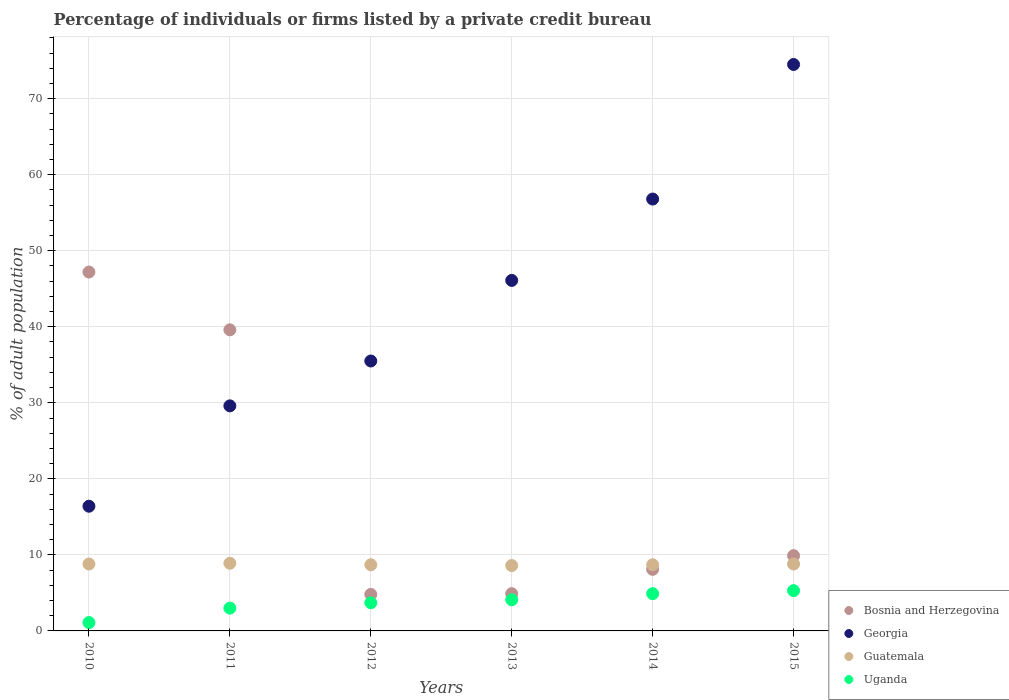Across all years, what is the maximum percentage of population listed by a private credit bureau in Uganda?
Offer a very short reply. 5.3. In which year was the percentage of population listed by a private credit bureau in Uganda maximum?
Ensure brevity in your answer.  2015. In which year was the percentage of population listed by a private credit bureau in Bosnia and Herzegovina minimum?
Offer a terse response. 2012. What is the total percentage of population listed by a private credit bureau in Georgia in the graph?
Give a very brief answer. 258.9. What is the difference between the percentage of population listed by a private credit bureau in Uganda in 2011 and that in 2015?
Give a very brief answer. -2.3. What is the difference between the percentage of population listed by a private credit bureau in Georgia in 2015 and the percentage of population listed by a private credit bureau in Uganda in 2013?
Offer a very short reply. 70.4. What is the average percentage of population listed by a private credit bureau in Uganda per year?
Your answer should be compact. 3.68. What is the difference between the highest and the second highest percentage of population listed by a private credit bureau in Georgia?
Make the answer very short. 17.7. What is the difference between the highest and the lowest percentage of population listed by a private credit bureau in Uganda?
Provide a succinct answer. 4.2. Does the percentage of population listed by a private credit bureau in Bosnia and Herzegovina monotonically increase over the years?
Make the answer very short. No. Is the percentage of population listed by a private credit bureau in Uganda strictly less than the percentage of population listed by a private credit bureau in Georgia over the years?
Your answer should be very brief. Yes. How many years are there in the graph?
Offer a very short reply. 6. What is the difference between two consecutive major ticks on the Y-axis?
Ensure brevity in your answer.  10. Does the graph contain any zero values?
Your answer should be very brief. No. How are the legend labels stacked?
Ensure brevity in your answer.  Vertical. What is the title of the graph?
Make the answer very short. Percentage of individuals or firms listed by a private credit bureau. What is the label or title of the X-axis?
Offer a very short reply. Years. What is the label or title of the Y-axis?
Offer a terse response. % of adult population. What is the % of adult population in Bosnia and Herzegovina in 2010?
Make the answer very short. 47.2. What is the % of adult population in Georgia in 2010?
Your response must be concise. 16.4. What is the % of adult population of Guatemala in 2010?
Ensure brevity in your answer.  8.8. What is the % of adult population of Bosnia and Herzegovina in 2011?
Provide a succinct answer. 39.6. What is the % of adult population in Georgia in 2011?
Ensure brevity in your answer.  29.6. What is the % of adult population of Georgia in 2012?
Provide a short and direct response. 35.5. What is the % of adult population in Uganda in 2012?
Offer a very short reply. 3.7. What is the % of adult population of Bosnia and Herzegovina in 2013?
Provide a short and direct response. 4.9. What is the % of adult population of Georgia in 2013?
Your answer should be very brief. 46.1. What is the % of adult population of Guatemala in 2013?
Your response must be concise. 8.6. What is the % of adult population of Bosnia and Herzegovina in 2014?
Make the answer very short. 8.1. What is the % of adult population in Georgia in 2014?
Your response must be concise. 56.8. What is the % of adult population of Guatemala in 2014?
Provide a succinct answer. 8.7. What is the % of adult population in Bosnia and Herzegovina in 2015?
Keep it short and to the point. 9.9. What is the % of adult population in Georgia in 2015?
Make the answer very short. 74.5. What is the % of adult population of Guatemala in 2015?
Your answer should be compact. 8.8. Across all years, what is the maximum % of adult population of Bosnia and Herzegovina?
Give a very brief answer. 47.2. Across all years, what is the maximum % of adult population of Georgia?
Offer a very short reply. 74.5. Across all years, what is the maximum % of adult population of Uganda?
Keep it short and to the point. 5.3. Across all years, what is the minimum % of adult population of Georgia?
Your response must be concise. 16.4. Across all years, what is the minimum % of adult population of Uganda?
Give a very brief answer. 1.1. What is the total % of adult population in Bosnia and Herzegovina in the graph?
Provide a short and direct response. 114.5. What is the total % of adult population of Georgia in the graph?
Make the answer very short. 258.9. What is the total % of adult population in Guatemala in the graph?
Your answer should be compact. 52.5. What is the total % of adult population of Uganda in the graph?
Ensure brevity in your answer.  22.1. What is the difference between the % of adult population of Bosnia and Herzegovina in 2010 and that in 2011?
Provide a succinct answer. 7.6. What is the difference between the % of adult population in Bosnia and Herzegovina in 2010 and that in 2012?
Your answer should be compact. 42.4. What is the difference between the % of adult population of Georgia in 2010 and that in 2012?
Provide a short and direct response. -19.1. What is the difference between the % of adult population of Guatemala in 2010 and that in 2012?
Offer a very short reply. 0.1. What is the difference between the % of adult population in Uganda in 2010 and that in 2012?
Keep it short and to the point. -2.6. What is the difference between the % of adult population in Bosnia and Herzegovina in 2010 and that in 2013?
Your answer should be compact. 42.3. What is the difference between the % of adult population of Georgia in 2010 and that in 2013?
Offer a terse response. -29.7. What is the difference between the % of adult population of Uganda in 2010 and that in 2013?
Your answer should be very brief. -3. What is the difference between the % of adult population in Bosnia and Herzegovina in 2010 and that in 2014?
Provide a short and direct response. 39.1. What is the difference between the % of adult population in Georgia in 2010 and that in 2014?
Offer a terse response. -40.4. What is the difference between the % of adult population in Bosnia and Herzegovina in 2010 and that in 2015?
Offer a very short reply. 37.3. What is the difference between the % of adult population in Georgia in 2010 and that in 2015?
Give a very brief answer. -58.1. What is the difference between the % of adult population in Uganda in 2010 and that in 2015?
Give a very brief answer. -4.2. What is the difference between the % of adult population of Bosnia and Herzegovina in 2011 and that in 2012?
Give a very brief answer. 34.8. What is the difference between the % of adult population in Georgia in 2011 and that in 2012?
Offer a very short reply. -5.9. What is the difference between the % of adult population in Guatemala in 2011 and that in 2012?
Your response must be concise. 0.2. What is the difference between the % of adult population in Bosnia and Herzegovina in 2011 and that in 2013?
Give a very brief answer. 34.7. What is the difference between the % of adult population of Georgia in 2011 and that in 2013?
Offer a very short reply. -16.5. What is the difference between the % of adult population of Bosnia and Herzegovina in 2011 and that in 2014?
Your answer should be very brief. 31.5. What is the difference between the % of adult population in Georgia in 2011 and that in 2014?
Offer a terse response. -27.2. What is the difference between the % of adult population of Guatemala in 2011 and that in 2014?
Your response must be concise. 0.2. What is the difference between the % of adult population of Uganda in 2011 and that in 2014?
Provide a short and direct response. -1.9. What is the difference between the % of adult population in Bosnia and Herzegovina in 2011 and that in 2015?
Keep it short and to the point. 29.7. What is the difference between the % of adult population in Georgia in 2011 and that in 2015?
Provide a succinct answer. -44.9. What is the difference between the % of adult population of Uganda in 2011 and that in 2015?
Your response must be concise. -2.3. What is the difference between the % of adult population in Uganda in 2012 and that in 2013?
Provide a short and direct response. -0.4. What is the difference between the % of adult population in Bosnia and Herzegovina in 2012 and that in 2014?
Make the answer very short. -3.3. What is the difference between the % of adult population in Georgia in 2012 and that in 2014?
Your answer should be very brief. -21.3. What is the difference between the % of adult population in Guatemala in 2012 and that in 2014?
Provide a short and direct response. 0. What is the difference between the % of adult population of Uganda in 2012 and that in 2014?
Offer a very short reply. -1.2. What is the difference between the % of adult population of Bosnia and Herzegovina in 2012 and that in 2015?
Your answer should be very brief. -5.1. What is the difference between the % of adult population in Georgia in 2012 and that in 2015?
Keep it short and to the point. -39. What is the difference between the % of adult population of Guatemala in 2012 and that in 2015?
Give a very brief answer. -0.1. What is the difference between the % of adult population of Uganda in 2012 and that in 2015?
Provide a short and direct response. -1.6. What is the difference between the % of adult population of Guatemala in 2013 and that in 2014?
Give a very brief answer. -0.1. What is the difference between the % of adult population of Uganda in 2013 and that in 2014?
Ensure brevity in your answer.  -0.8. What is the difference between the % of adult population in Georgia in 2013 and that in 2015?
Provide a short and direct response. -28.4. What is the difference between the % of adult population in Bosnia and Herzegovina in 2014 and that in 2015?
Ensure brevity in your answer.  -1.8. What is the difference between the % of adult population in Georgia in 2014 and that in 2015?
Your answer should be very brief. -17.7. What is the difference between the % of adult population in Uganda in 2014 and that in 2015?
Offer a very short reply. -0.4. What is the difference between the % of adult population of Bosnia and Herzegovina in 2010 and the % of adult population of Georgia in 2011?
Make the answer very short. 17.6. What is the difference between the % of adult population in Bosnia and Herzegovina in 2010 and the % of adult population in Guatemala in 2011?
Provide a succinct answer. 38.3. What is the difference between the % of adult population in Bosnia and Herzegovina in 2010 and the % of adult population in Uganda in 2011?
Your answer should be very brief. 44.2. What is the difference between the % of adult population in Guatemala in 2010 and the % of adult population in Uganda in 2011?
Give a very brief answer. 5.8. What is the difference between the % of adult population in Bosnia and Herzegovina in 2010 and the % of adult population in Georgia in 2012?
Offer a terse response. 11.7. What is the difference between the % of adult population of Bosnia and Herzegovina in 2010 and the % of adult population of Guatemala in 2012?
Make the answer very short. 38.5. What is the difference between the % of adult population of Bosnia and Herzegovina in 2010 and the % of adult population of Uganda in 2012?
Your answer should be compact. 43.5. What is the difference between the % of adult population of Georgia in 2010 and the % of adult population of Guatemala in 2012?
Give a very brief answer. 7.7. What is the difference between the % of adult population in Bosnia and Herzegovina in 2010 and the % of adult population in Guatemala in 2013?
Make the answer very short. 38.6. What is the difference between the % of adult population of Bosnia and Herzegovina in 2010 and the % of adult population of Uganda in 2013?
Your answer should be compact. 43.1. What is the difference between the % of adult population of Georgia in 2010 and the % of adult population of Guatemala in 2013?
Give a very brief answer. 7.8. What is the difference between the % of adult population of Georgia in 2010 and the % of adult population of Uganda in 2013?
Offer a terse response. 12.3. What is the difference between the % of adult population of Guatemala in 2010 and the % of adult population of Uganda in 2013?
Make the answer very short. 4.7. What is the difference between the % of adult population in Bosnia and Herzegovina in 2010 and the % of adult population in Guatemala in 2014?
Your answer should be very brief. 38.5. What is the difference between the % of adult population of Bosnia and Herzegovina in 2010 and the % of adult population of Uganda in 2014?
Your response must be concise. 42.3. What is the difference between the % of adult population of Georgia in 2010 and the % of adult population of Uganda in 2014?
Give a very brief answer. 11.5. What is the difference between the % of adult population in Bosnia and Herzegovina in 2010 and the % of adult population in Georgia in 2015?
Make the answer very short. -27.3. What is the difference between the % of adult population in Bosnia and Herzegovina in 2010 and the % of adult population in Guatemala in 2015?
Offer a terse response. 38.4. What is the difference between the % of adult population of Bosnia and Herzegovina in 2010 and the % of adult population of Uganda in 2015?
Your answer should be very brief. 41.9. What is the difference between the % of adult population in Georgia in 2010 and the % of adult population in Guatemala in 2015?
Give a very brief answer. 7.6. What is the difference between the % of adult population of Bosnia and Herzegovina in 2011 and the % of adult population of Georgia in 2012?
Provide a short and direct response. 4.1. What is the difference between the % of adult population in Bosnia and Herzegovina in 2011 and the % of adult population in Guatemala in 2012?
Offer a very short reply. 30.9. What is the difference between the % of adult population of Bosnia and Herzegovina in 2011 and the % of adult population of Uganda in 2012?
Ensure brevity in your answer.  35.9. What is the difference between the % of adult population of Georgia in 2011 and the % of adult population of Guatemala in 2012?
Offer a terse response. 20.9. What is the difference between the % of adult population of Georgia in 2011 and the % of adult population of Uganda in 2012?
Make the answer very short. 25.9. What is the difference between the % of adult population of Bosnia and Herzegovina in 2011 and the % of adult population of Guatemala in 2013?
Your answer should be compact. 31. What is the difference between the % of adult population in Bosnia and Herzegovina in 2011 and the % of adult population in Uganda in 2013?
Offer a terse response. 35.5. What is the difference between the % of adult population in Georgia in 2011 and the % of adult population in Guatemala in 2013?
Your response must be concise. 21. What is the difference between the % of adult population in Guatemala in 2011 and the % of adult population in Uganda in 2013?
Offer a terse response. 4.8. What is the difference between the % of adult population in Bosnia and Herzegovina in 2011 and the % of adult population in Georgia in 2014?
Offer a very short reply. -17.2. What is the difference between the % of adult population in Bosnia and Herzegovina in 2011 and the % of adult population in Guatemala in 2014?
Keep it short and to the point. 30.9. What is the difference between the % of adult population of Bosnia and Herzegovina in 2011 and the % of adult population of Uganda in 2014?
Give a very brief answer. 34.7. What is the difference between the % of adult population in Georgia in 2011 and the % of adult population in Guatemala in 2014?
Provide a short and direct response. 20.9. What is the difference between the % of adult population in Georgia in 2011 and the % of adult population in Uganda in 2014?
Make the answer very short. 24.7. What is the difference between the % of adult population in Guatemala in 2011 and the % of adult population in Uganda in 2014?
Offer a very short reply. 4. What is the difference between the % of adult population of Bosnia and Herzegovina in 2011 and the % of adult population of Georgia in 2015?
Provide a succinct answer. -34.9. What is the difference between the % of adult population in Bosnia and Herzegovina in 2011 and the % of adult population in Guatemala in 2015?
Make the answer very short. 30.8. What is the difference between the % of adult population in Bosnia and Herzegovina in 2011 and the % of adult population in Uganda in 2015?
Make the answer very short. 34.3. What is the difference between the % of adult population of Georgia in 2011 and the % of adult population of Guatemala in 2015?
Provide a succinct answer. 20.8. What is the difference between the % of adult population of Georgia in 2011 and the % of adult population of Uganda in 2015?
Keep it short and to the point. 24.3. What is the difference between the % of adult population of Bosnia and Herzegovina in 2012 and the % of adult population of Georgia in 2013?
Make the answer very short. -41.3. What is the difference between the % of adult population of Bosnia and Herzegovina in 2012 and the % of adult population of Uganda in 2013?
Provide a short and direct response. 0.7. What is the difference between the % of adult population in Georgia in 2012 and the % of adult population in Guatemala in 2013?
Your response must be concise. 26.9. What is the difference between the % of adult population in Georgia in 2012 and the % of adult population in Uganda in 2013?
Ensure brevity in your answer.  31.4. What is the difference between the % of adult population of Guatemala in 2012 and the % of adult population of Uganda in 2013?
Make the answer very short. 4.6. What is the difference between the % of adult population in Bosnia and Herzegovina in 2012 and the % of adult population in Georgia in 2014?
Your answer should be compact. -52. What is the difference between the % of adult population in Bosnia and Herzegovina in 2012 and the % of adult population in Guatemala in 2014?
Provide a short and direct response. -3.9. What is the difference between the % of adult population in Bosnia and Herzegovina in 2012 and the % of adult population in Uganda in 2014?
Give a very brief answer. -0.1. What is the difference between the % of adult population of Georgia in 2012 and the % of adult population of Guatemala in 2014?
Your answer should be very brief. 26.8. What is the difference between the % of adult population in Georgia in 2012 and the % of adult population in Uganda in 2014?
Make the answer very short. 30.6. What is the difference between the % of adult population in Guatemala in 2012 and the % of adult population in Uganda in 2014?
Offer a terse response. 3.8. What is the difference between the % of adult population in Bosnia and Herzegovina in 2012 and the % of adult population in Georgia in 2015?
Provide a succinct answer. -69.7. What is the difference between the % of adult population in Bosnia and Herzegovina in 2012 and the % of adult population in Uganda in 2015?
Ensure brevity in your answer.  -0.5. What is the difference between the % of adult population of Georgia in 2012 and the % of adult population of Guatemala in 2015?
Ensure brevity in your answer.  26.7. What is the difference between the % of adult population in Georgia in 2012 and the % of adult population in Uganda in 2015?
Provide a short and direct response. 30.2. What is the difference between the % of adult population of Bosnia and Herzegovina in 2013 and the % of adult population of Georgia in 2014?
Offer a very short reply. -51.9. What is the difference between the % of adult population in Bosnia and Herzegovina in 2013 and the % of adult population in Guatemala in 2014?
Your answer should be very brief. -3.8. What is the difference between the % of adult population of Georgia in 2013 and the % of adult population of Guatemala in 2014?
Provide a succinct answer. 37.4. What is the difference between the % of adult population in Georgia in 2013 and the % of adult population in Uganda in 2014?
Your response must be concise. 41.2. What is the difference between the % of adult population in Bosnia and Herzegovina in 2013 and the % of adult population in Georgia in 2015?
Your answer should be compact. -69.6. What is the difference between the % of adult population of Georgia in 2013 and the % of adult population of Guatemala in 2015?
Give a very brief answer. 37.3. What is the difference between the % of adult population of Georgia in 2013 and the % of adult population of Uganda in 2015?
Offer a terse response. 40.8. What is the difference between the % of adult population of Bosnia and Herzegovina in 2014 and the % of adult population of Georgia in 2015?
Give a very brief answer. -66.4. What is the difference between the % of adult population in Georgia in 2014 and the % of adult population in Uganda in 2015?
Your response must be concise. 51.5. What is the difference between the % of adult population in Guatemala in 2014 and the % of adult population in Uganda in 2015?
Give a very brief answer. 3.4. What is the average % of adult population in Bosnia and Herzegovina per year?
Give a very brief answer. 19.08. What is the average % of adult population in Georgia per year?
Your response must be concise. 43.15. What is the average % of adult population of Guatemala per year?
Ensure brevity in your answer.  8.75. What is the average % of adult population in Uganda per year?
Your answer should be very brief. 3.68. In the year 2010, what is the difference between the % of adult population of Bosnia and Herzegovina and % of adult population of Georgia?
Your response must be concise. 30.8. In the year 2010, what is the difference between the % of adult population of Bosnia and Herzegovina and % of adult population of Guatemala?
Your response must be concise. 38.4. In the year 2010, what is the difference between the % of adult population of Bosnia and Herzegovina and % of adult population of Uganda?
Your response must be concise. 46.1. In the year 2010, what is the difference between the % of adult population of Georgia and % of adult population of Guatemala?
Ensure brevity in your answer.  7.6. In the year 2010, what is the difference between the % of adult population of Guatemala and % of adult population of Uganda?
Offer a very short reply. 7.7. In the year 2011, what is the difference between the % of adult population in Bosnia and Herzegovina and % of adult population in Georgia?
Provide a short and direct response. 10. In the year 2011, what is the difference between the % of adult population in Bosnia and Herzegovina and % of adult population in Guatemala?
Your answer should be compact. 30.7. In the year 2011, what is the difference between the % of adult population in Bosnia and Herzegovina and % of adult population in Uganda?
Offer a very short reply. 36.6. In the year 2011, what is the difference between the % of adult population of Georgia and % of adult population of Guatemala?
Offer a very short reply. 20.7. In the year 2011, what is the difference between the % of adult population in Georgia and % of adult population in Uganda?
Provide a succinct answer. 26.6. In the year 2012, what is the difference between the % of adult population of Bosnia and Herzegovina and % of adult population of Georgia?
Keep it short and to the point. -30.7. In the year 2012, what is the difference between the % of adult population in Bosnia and Herzegovina and % of adult population in Uganda?
Ensure brevity in your answer.  1.1. In the year 2012, what is the difference between the % of adult population in Georgia and % of adult population in Guatemala?
Give a very brief answer. 26.8. In the year 2012, what is the difference between the % of adult population in Georgia and % of adult population in Uganda?
Your response must be concise. 31.8. In the year 2013, what is the difference between the % of adult population of Bosnia and Herzegovina and % of adult population of Georgia?
Provide a short and direct response. -41.2. In the year 2013, what is the difference between the % of adult population of Bosnia and Herzegovina and % of adult population of Uganda?
Provide a short and direct response. 0.8. In the year 2013, what is the difference between the % of adult population of Georgia and % of adult population of Guatemala?
Make the answer very short. 37.5. In the year 2013, what is the difference between the % of adult population of Guatemala and % of adult population of Uganda?
Your answer should be compact. 4.5. In the year 2014, what is the difference between the % of adult population in Bosnia and Herzegovina and % of adult population in Georgia?
Offer a terse response. -48.7. In the year 2014, what is the difference between the % of adult population of Georgia and % of adult population of Guatemala?
Your answer should be compact. 48.1. In the year 2014, what is the difference between the % of adult population of Georgia and % of adult population of Uganda?
Give a very brief answer. 51.9. In the year 2015, what is the difference between the % of adult population of Bosnia and Herzegovina and % of adult population of Georgia?
Offer a terse response. -64.6. In the year 2015, what is the difference between the % of adult population in Bosnia and Herzegovina and % of adult population in Guatemala?
Offer a terse response. 1.1. In the year 2015, what is the difference between the % of adult population in Georgia and % of adult population in Guatemala?
Ensure brevity in your answer.  65.7. In the year 2015, what is the difference between the % of adult population of Georgia and % of adult population of Uganda?
Offer a terse response. 69.2. In the year 2015, what is the difference between the % of adult population in Guatemala and % of adult population in Uganda?
Keep it short and to the point. 3.5. What is the ratio of the % of adult population of Bosnia and Herzegovina in 2010 to that in 2011?
Give a very brief answer. 1.19. What is the ratio of the % of adult population in Georgia in 2010 to that in 2011?
Make the answer very short. 0.55. What is the ratio of the % of adult population of Uganda in 2010 to that in 2011?
Your answer should be compact. 0.37. What is the ratio of the % of adult population of Bosnia and Herzegovina in 2010 to that in 2012?
Make the answer very short. 9.83. What is the ratio of the % of adult population of Georgia in 2010 to that in 2012?
Your answer should be compact. 0.46. What is the ratio of the % of adult population of Guatemala in 2010 to that in 2012?
Offer a very short reply. 1.01. What is the ratio of the % of adult population in Uganda in 2010 to that in 2012?
Offer a very short reply. 0.3. What is the ratio of the % of adult population in Bosnia and Herzegovina in 2010 to that in 2013?
Offer a very short reply. 9.63. What is the ratio of the % of adult population in Georgia in 2010 to that in 2013?
Keep it short and to the point. 0.36. What is the ratio of the % of adult population of Guatemala in 2010 to that in 2013?
Ensure brevity in your answer.  1.02. What is the ratio of the % of adult population in Uganda in 2010 to that in 2013?
Offer a terse response. 0.27. What is the ratio of the % of adult population in Bosnia and Herzegovina in 2010 to that in 2014?
Give a very brief answer. 5.83. What is the ratio of the % of adult population in Georgia in 2010 to that in 2014?
Your response must be concise. 0.29. What is the ratio of the % of adult population in Guatemala in 2010 to that in 2014?
Keep it short and to the point. 1.01. What is the ratio of the % of adult population in Uganda in 2010 to that in 2014?
Ensure brevity in your answer.  0.22. What is the ratio of the % of adult population of Bosnia and Herzegovina in 2010 to that in 2015?
Give a very brief answer. 4.77. What is the ratio of the % of adult population of Georgia in 2010 to that in 2015?
Make the answer very short. 0.22. What is the ratio of the % of adult population in Guatemala in 2010 to that in 2015?
Offer a terse response. 1. What is the ratio of the % of adult population of Uganda in 2010 to that in 2015?
Offer a terse response. 0.21. What is the ratio of the % of adult population of Bosnia and Herzegovina in 2011 to that in 2012?
Make the answer very short. 8.25. What is the ratio of the % of adult population in Georgia in 2011 to that in 2012?
Offer a very short reply. 0.83. What is the ratio of the % of adult population in Guatemala in 2011 to that in 2012?
Offer a very short reply. 1.02. What is the ratio of the % of adult population of Uganda in 2011 to that in 2012?
Offer a very short reply. 0.81. What is the ratio of the % of adult population of Bosnia and Herzegovina in 2011 to that in 2013?
Your response must be concise. 8.08. What is the ratio of the % of adult population of Georgia in 2011 to that in 2013?
Offer a very short reply. 0.64. What is the ratio of the % of adult population of Guatemala in 2011 to that in 2013?
Provide a short and direct response. 1.03. What is the ratio of the % of adult population in Uganda in 2011 to that in 2013?
Make the answer very short. 0.73. What is the ratio of the % of adult population in Bosnia and Herzegovina in 2011 to that in 2014?
Provide a succinct answer. 4.89. What is the ratio of the % of adult population of Georgia in 2011 to that in 2014?
Ensure brevity in your answer.  0.52. What is the ratio of the % of adult population of Uganda in 2011 to that in 2014?
Ensure brevity in your answer.  0.61. What is the ratio of the % of adult population of Georgia in 2011 to that in 2015?
Make the answer very short. 0.4. What is the ratio of the % of adult population of Guatemala in 2011 to that in 2015?
Give a very brief answer. 1.01. What is the ratio of the % of adult population in Uganda in 2011 to that in 2015?
Your answer should be very brief. 0.57. What is the ratio of the % of adult population in Bosnia and Herzegovina in 2012 to that in 2013?
Offer a very short reply. 0.98. What is the ratio of the % of adult population of Georgia in 2012 to that in 2013?
Your answer should be compact. 0.77. What is the ratio of the % of adult population of Guatemala in 2012 to that in 2013?
Provide a succinct answer. 1.01. What is the ratio of the % of adult population in Uganda in 2012 to that in 2013?
Provide a short and direct response. 0.9. What is the ratio of the % of adult population in Bosnia and Herzegovina in 2012 to that in 2014?
Offer a very short reply. 0.59. What is the ratio of the % of adult population in Guatemala in 2012 to that in 2014?
Ensure brevity in your answer.  1. What is the ratio of the % of adult population of Uganda in 2012 to that in 2014?
Give a very brief answer. 0.76. What is the ratio of the % of adult population of Bosnia and Herzegovina in 2012 to that in 2015?
Provide a succinct answer. 0.48. What is the ratio of the % of adult population in Georgia in 2012 to that in 2015?
Make the answer very short. 0.48. What is the ratio of the % of adult population in Guatemala in 2012 to that in 2015?
Make the answer very short. 0.99. What is the ratio of the % of adult population in Uganda in 2012 to that in 2015?
Offer a terse response. 0.7. What is the ratio of the % of adult population in Bosnia and Herzegovina in 2013 to that in 2014?
Offer a terse response. 0.6. What is the ratio of the % of adult population in Georgia in 2013 to that in 2014?
Ensure brevity in your answer.  0.81. What is the ratio of the % of adult population of Uganda in 2013 to that in 2014?
Make the answer very short. 0.84. What is the ratio of the % of adult population in Bosnia and Herzegovina in 2013 to that in 2015?
Offer a terse response. 0.49. What is the ratio of the % of adult population in Georgia in 2013 to that in 2015?
Your answer should be very brief. 0.62. What is the ratio of the % of adult population of Guatemala in 2013 to that in 2015?
Provide a succinct answer. 0.98. What is the ratio of the % of adult population of Uganda in 2013 to that in 2015?
Provide a short and direct response. 0.77. What is the ratio of the % of adult population of Bosnia and Herzegovina in 2014 to that in 2015?
Give a very brief answer. 0.82. What is the ratio of the % of adult population of Georgia in 2014 to that in 2015?
Your answer should be very brief. 0.76. What is the ratio of the % of adult population in Uganda in 2014 to that in 2015?
Make the answer very short. 0.92. What is the difference between the highest and the second highest % of adult population in Georgia?
Offer a terse response. 17.7. What is the difference between the highest and the second highest % of adult population of Guatemala?
Ensure brevity in your answer.  0.1. What is the difference between the highest and the second highest % of adult population in Uganda?
Ensure brevity in your answer.  0.4. What is the difference between the highest and the lowest % of adult population in Bosnia and Herzegovina?
Make the answer very short. 42.4. What is the difference between the highest and the lowest % of adult population in Georgia?
Provide a short and direct response. 58.1. What is the difference between the highest and the lowest % of adult population in Uganda?
Make the answer very short. 4.2. 